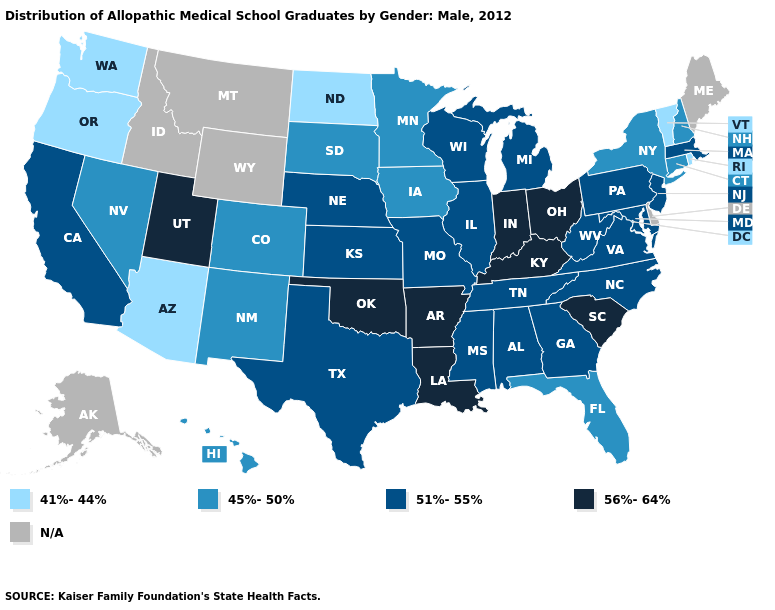Among the states that border North Dakota , which have the highest value?
Concise answer only. Minnesota, South Dakota. What is the highest value in the USA?
Keep it brief. 56%-64%. What is the value of Maryland?
Quick response, please. 51%-55%. Which states have the lowest value in the South?
Answer briefly. Florida. Does Ohio have the highest value in the MidWest?
Answer briefly. Yes. What is the lowest value in the Northeast?
Give a very brief answer. 41%-44%. What is the lowest value in states that border Texas?
Quick response, please. 45%-50%. Name the states that have a value in the range 51%-55%?
Concise answer only. Alabama, California, Georgia, Illinois, Kansas, Maryland, Massachusetts, Michigan, Mississippi, Missouri, Nebraska, New Jersey, North Carolina, Pennsylvania, Tennessee, Texas, Virginia, West Virginia, Wisconsin. What is the value of Maine?
Answer briefly. N/A. Name the states that have a value in the range 41%-44%?
Concise answer only. Arizona, North Dakota, Oregon, Rhode Island, Vermont, Washington. What is the value of Idaho?
Keep it brief. N/A. 